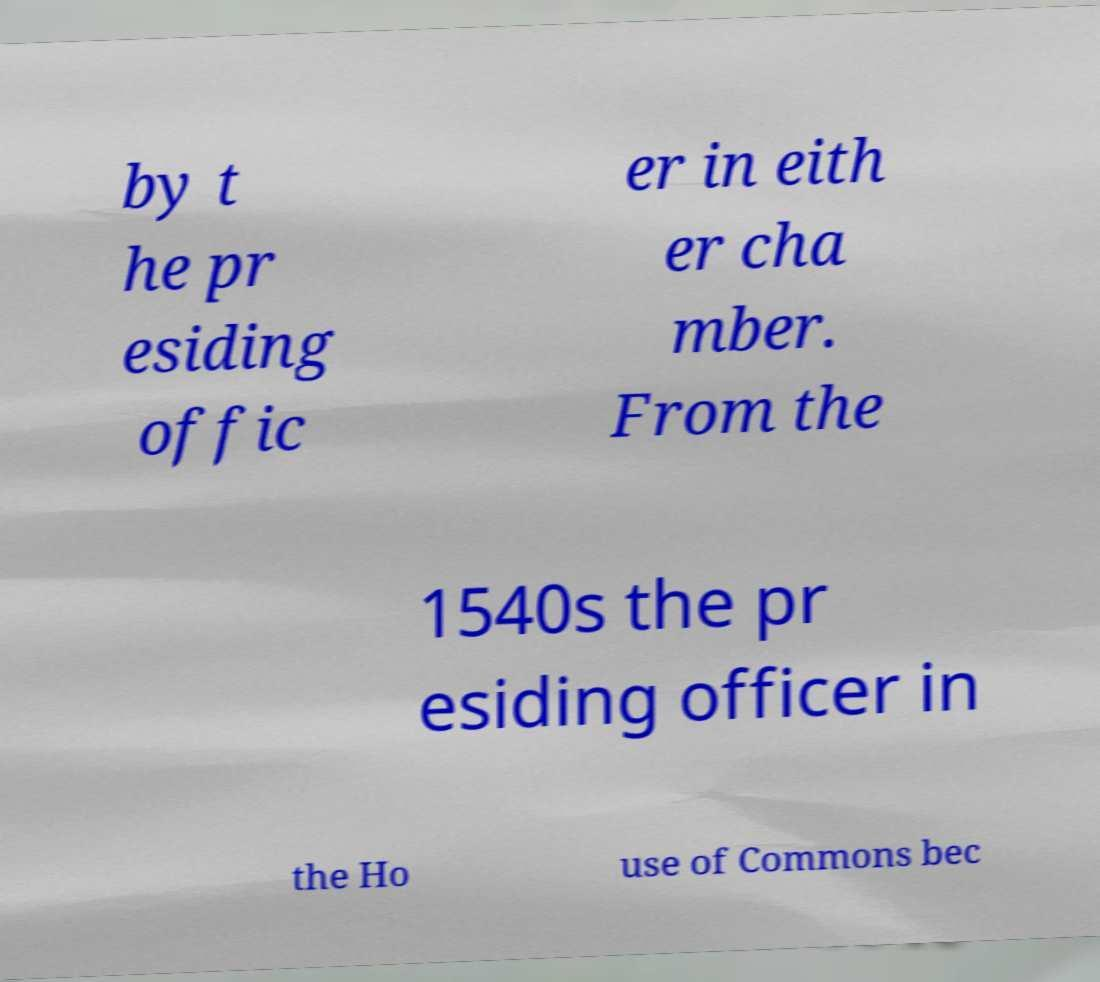Can you read and provide the text displayed in the image?This photo seems to have some interesting text. Can you extract and type it out for me? by t he pr esiding offic er in eith er cha mber. From the 1540s the pr esiding officer in the Ho use of Commons bec 